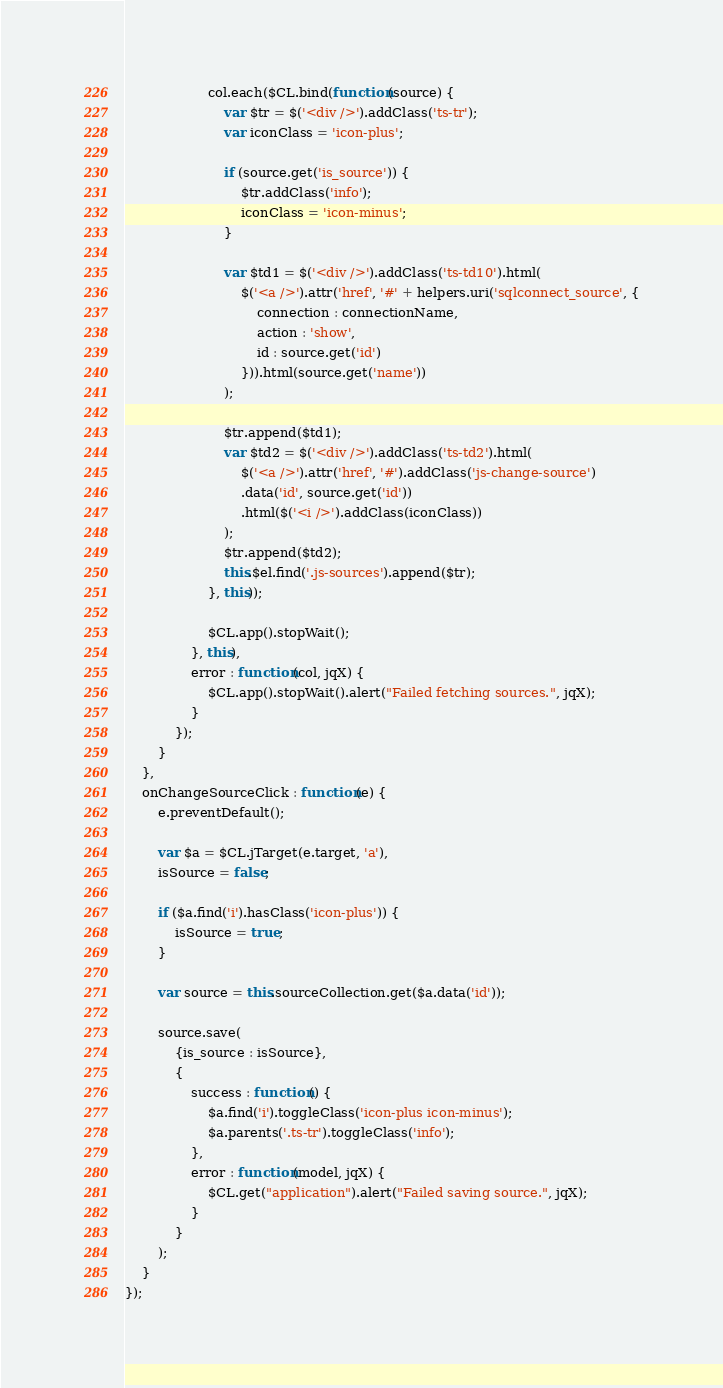<code> <loc_0><loc_0><loc_500><loc_500><_JavaScript_>                    col.each($CL.bind(function(source) {
                        var $tr = $('<div />').addClass('ts-tr');
                        var iconClass = 'icon-plus';

                        if (source.get('is_source')) {
                            $tr.addClass('info');
                            iconClass = 'icon-minus';
                        }

                        var $td1 = $('<div />').addClass('ts-td10').html(
                            $('<a />').attr('href', '#' + helpers.uri('sqlconnect_source', {
                                connection : connectionName,
                                action : 'show',
                                id : source.get('id')
                            })).html(source.get('name'))
                        );

                        $tr.append($td1);
                        var $td2 = $('<div />').addClass('ts-td2').html(
                            $('<a />').attr('href', '#').addClass('js-change-source')
                            .data('id', source.get('id'))
                            .html($('<i />').addClass(iconClass))
                        );
                        $tr.append($td2);
                        this.$el.find('.js-sources').append($tr);
                    }, this));

                    $CL.app().stopWait();
                }, this),
                error : function(col, jqX) {
                    $CL.app().stopWait().alert("Failed fetching sources.", jqX);
                }
            });
        }
    },
    onChangeSourceClick : function(e) {
        e.preventDefault();

        var $a = $CL.jTarget(e.target, 'a'),
        isSource = false;

        if ($a.find('i').hasClass('icon-plus')) {
            isSource = true;
        }

        var source = this.sourceCollection.get($a.data('id'));

        source.save(
            {is_source : isSource},
            {
                success : function() {
                    $a.find('i').toggleClass('icon-plus icon-minus');
                    $a.parents('.ts-tr').toggleClass('info');
                },
                error : function(model, jqX) {
                    $CL.get("application").alert("Failed saving source.", jqX);
                }
            }
        );
    }
});</code> 